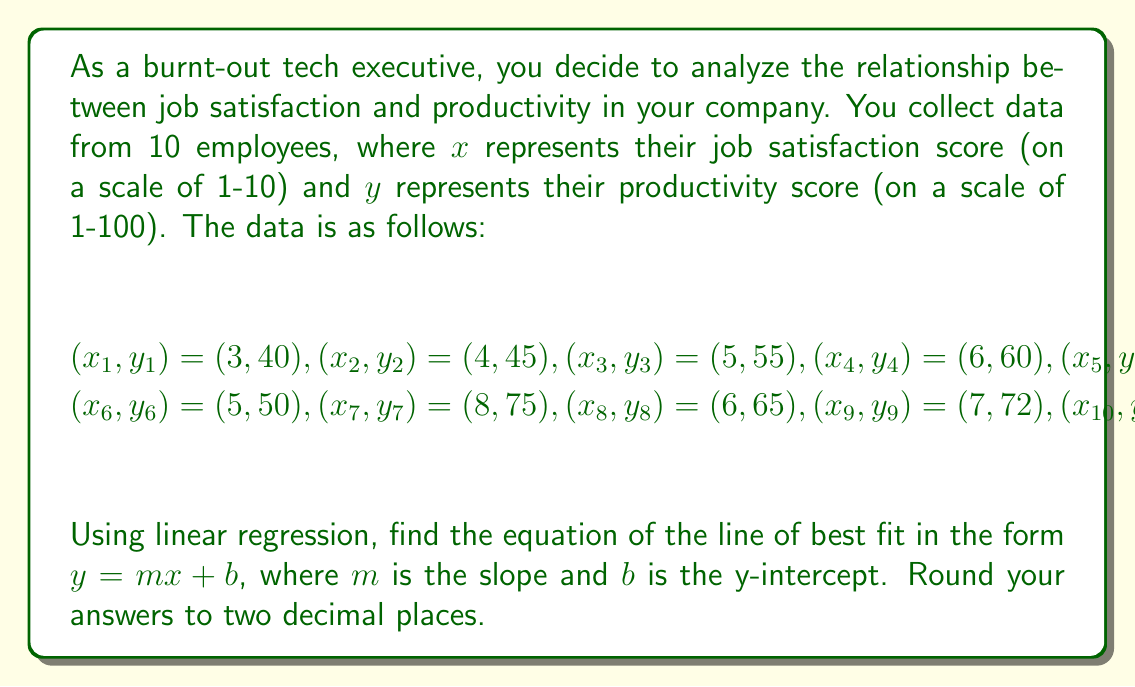Can you solve this math problem? To find the line of best fit using linear regression, we need to calculate the slope (m) and y-intercept (b) using the following formulas:

$$m = \frac{n\sum xy - \sum x \sum y}{n\sum x^2 - (\sum x)^2}$$

$$b = \frac{\sum y - m\sum x}{n}$$

Where n is the number of data points (in this case, n = 10).

Step 1: Calculate the necessary sums:
$\sum x = 3 + 4 + 5 + 6 + 7 + 5 + 8 + 6 + 7 + 9 = 60$
$\sum y = 40 + 45 + 55 + 60 + 70 + 50 + 75 + 65 + 72 + 85 = 617$
$\sum xy = (3 \times 40) + (4 \times 45) + ... + (9 \times 85) = 3,947$
$\sum x^2 = 3^2 + 4^2 + ... + 9^2 = 396$

Step 2: Calculate the slope (m):
$$m = \frac{10(3,947) - 60(617)}{10(396) - 60^2}$$
$$m = \frac{39,470 - 37,020}{3,960 - 3,600}$$
$$m = \frac{2,450}{360} \approx 6.81$$

Step 3: Calculate the y-intercept (b):
$$b = \frac{617 - 6.81(60)}{10}$$
$$b = \frac{617 - 408.60}{10}$$
$$b = \frac{208.40}{10} \approx 20.84$$

Step 4: Form the equation of the line of best fit:
$y = 6.81x + 20.84$

Rounding to two decimal places, we get:
$y = 6.81x + 20.84$
Answer: The equation of the line of best fit is $y = 6.81x + 20.84$, where m = 6.81 and b = 20.84 (rounded to two decimal places). 